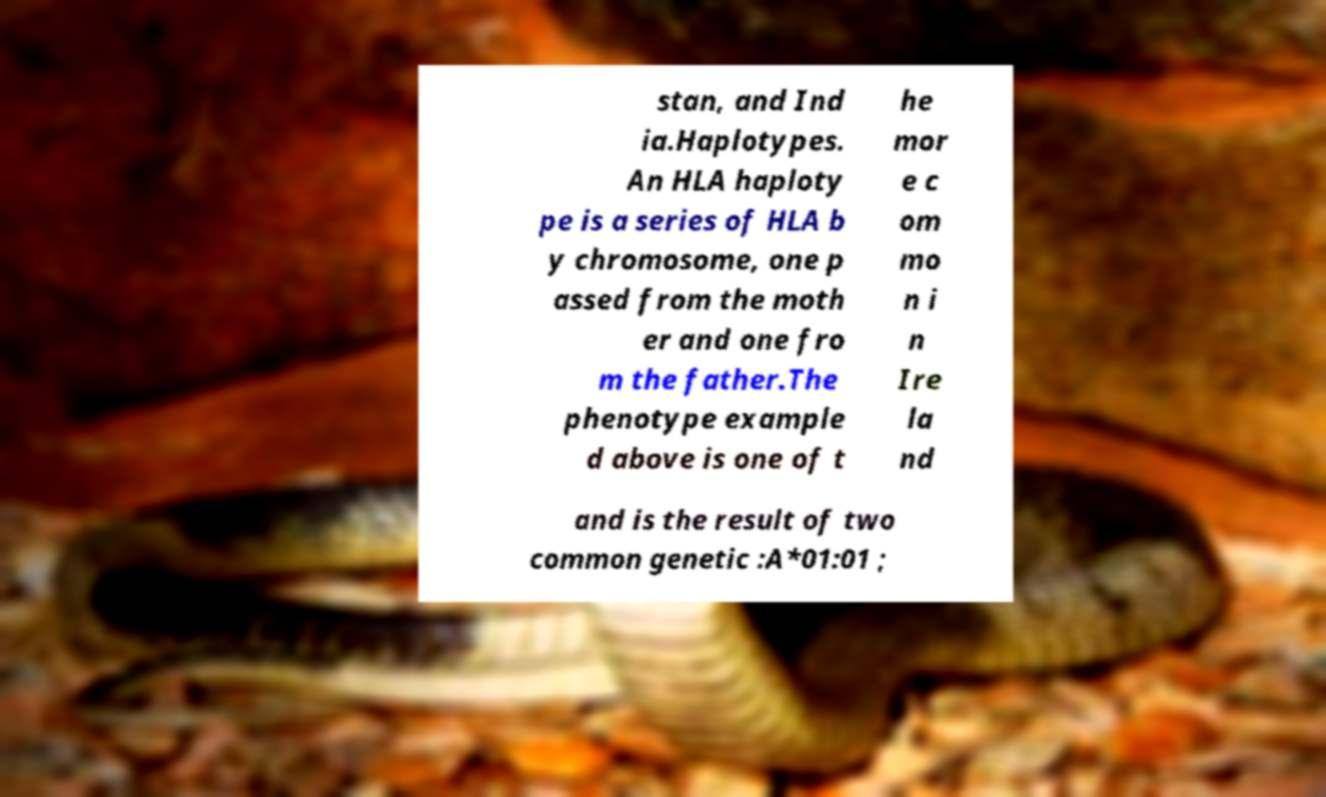I need the written content from this picture converted into text. Can you do that? stan, and Ind ia.Haplotypes. An HLA haploty pe is a series of HLA b y chromosome, one p assed from the moth er and one fro m the father.The phenotype example d above is one of t he mor e c om mo n i n Ire la nd and is the result of two common genetic :A*01:01 ; 